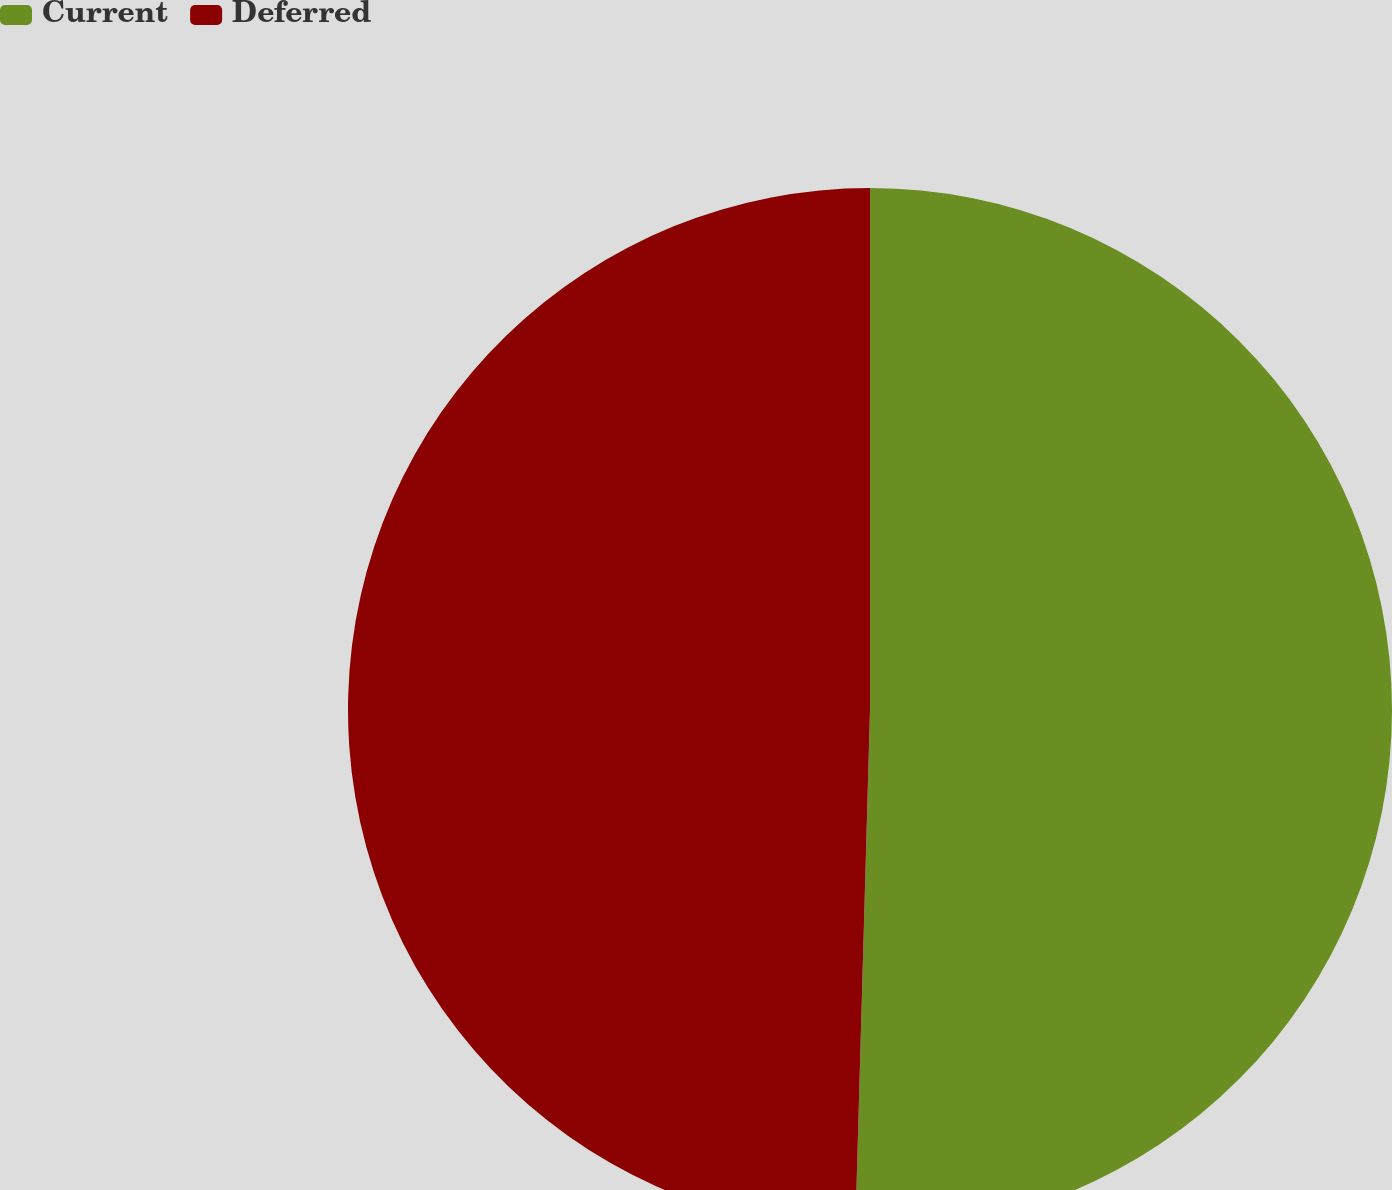<chart> <loc_0><loc_0><loc_500><loc_500><pie_chart><fcel>Current<fcel>Deferred<nl><fcel>50.45%<fcel>49.55%<nl></chart> 